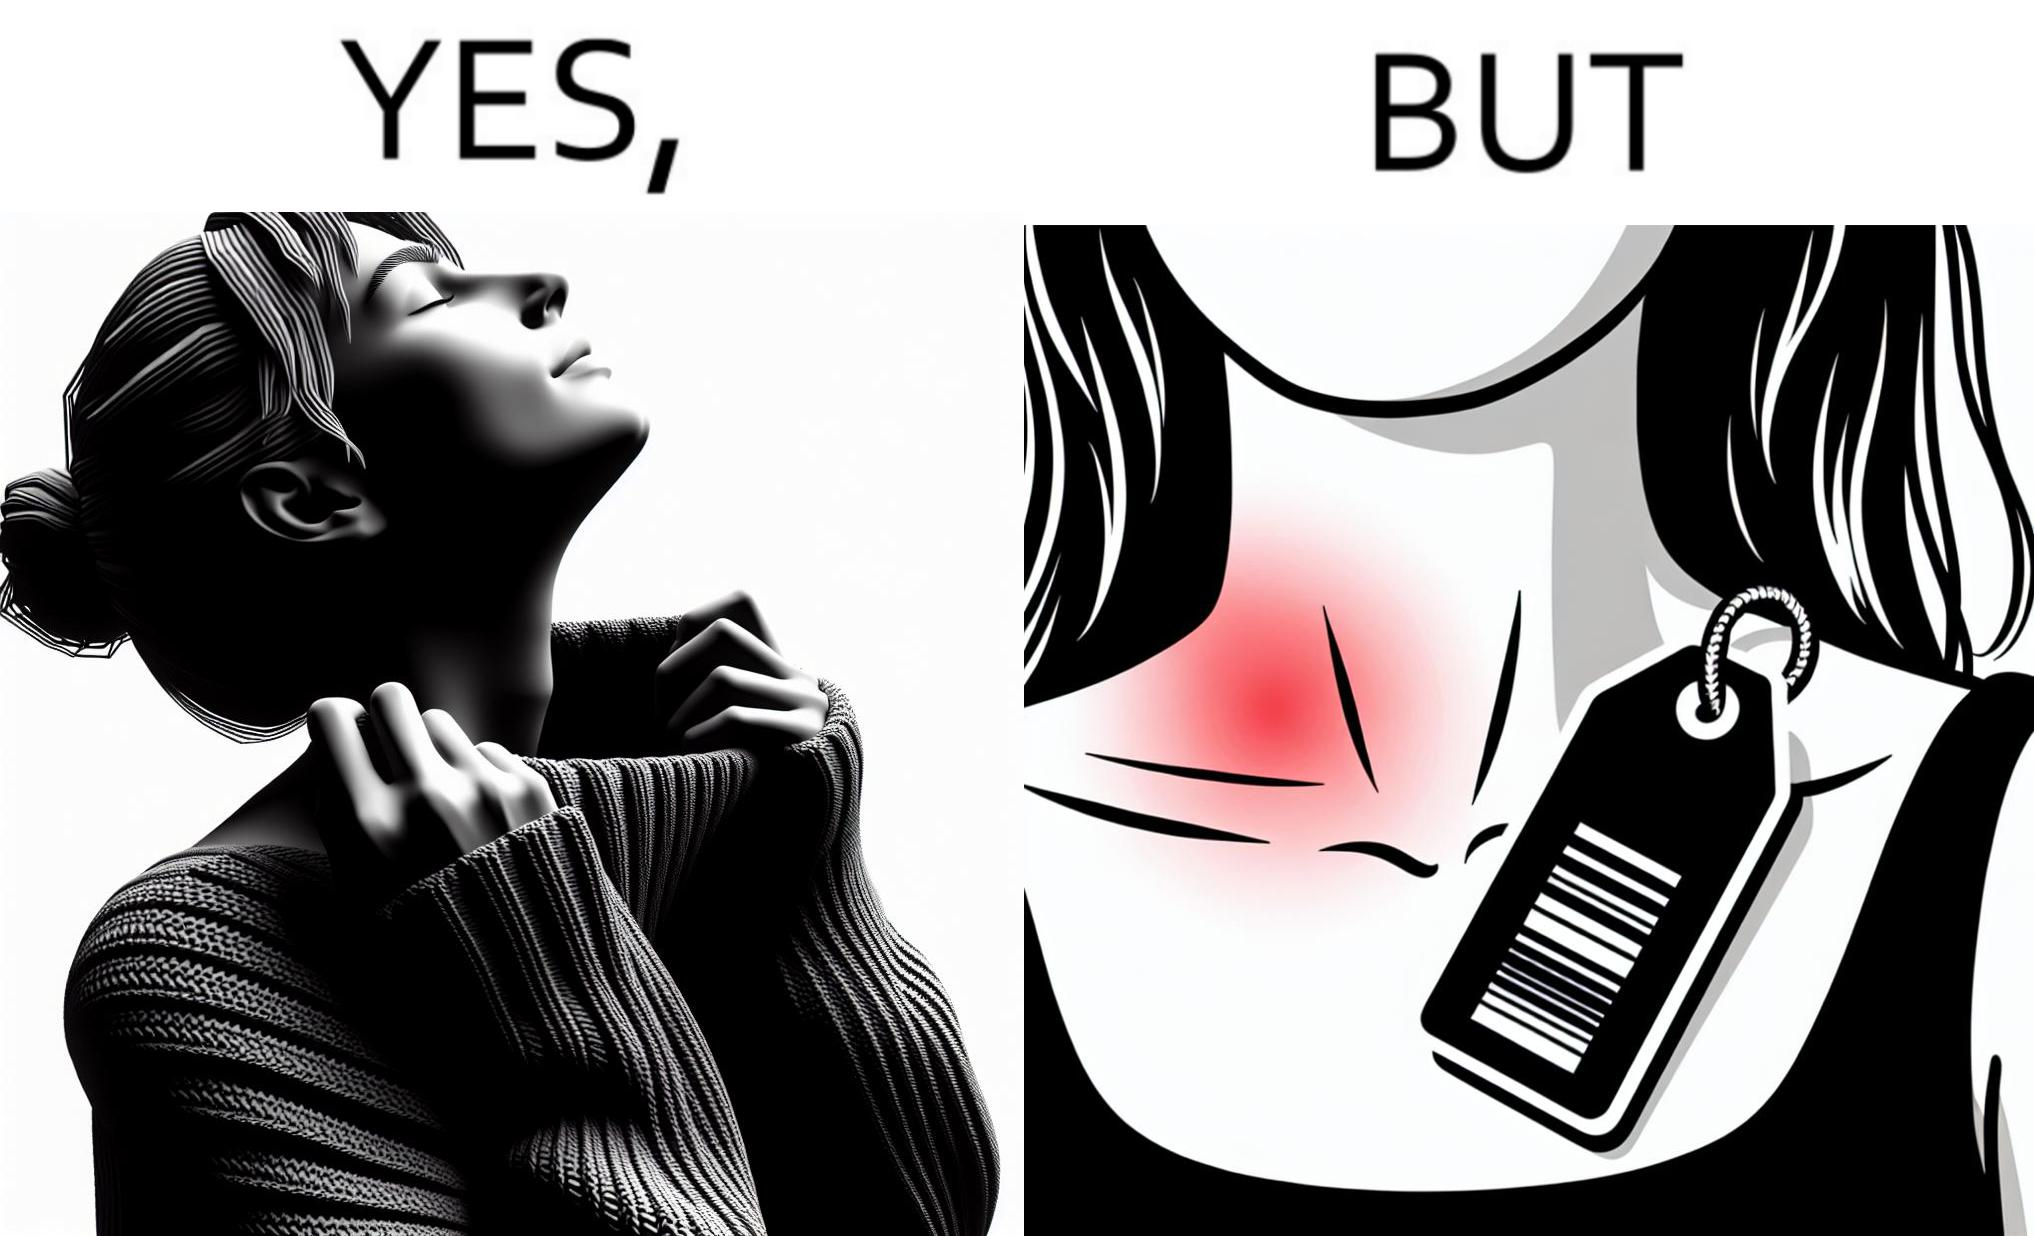Provide a description of this image. The images are funny since it shows how even though sweaters and other clothings provide much comfort, a tiny manufacturers tag ends up causing the user a lot of discomfort due to constant scratching 